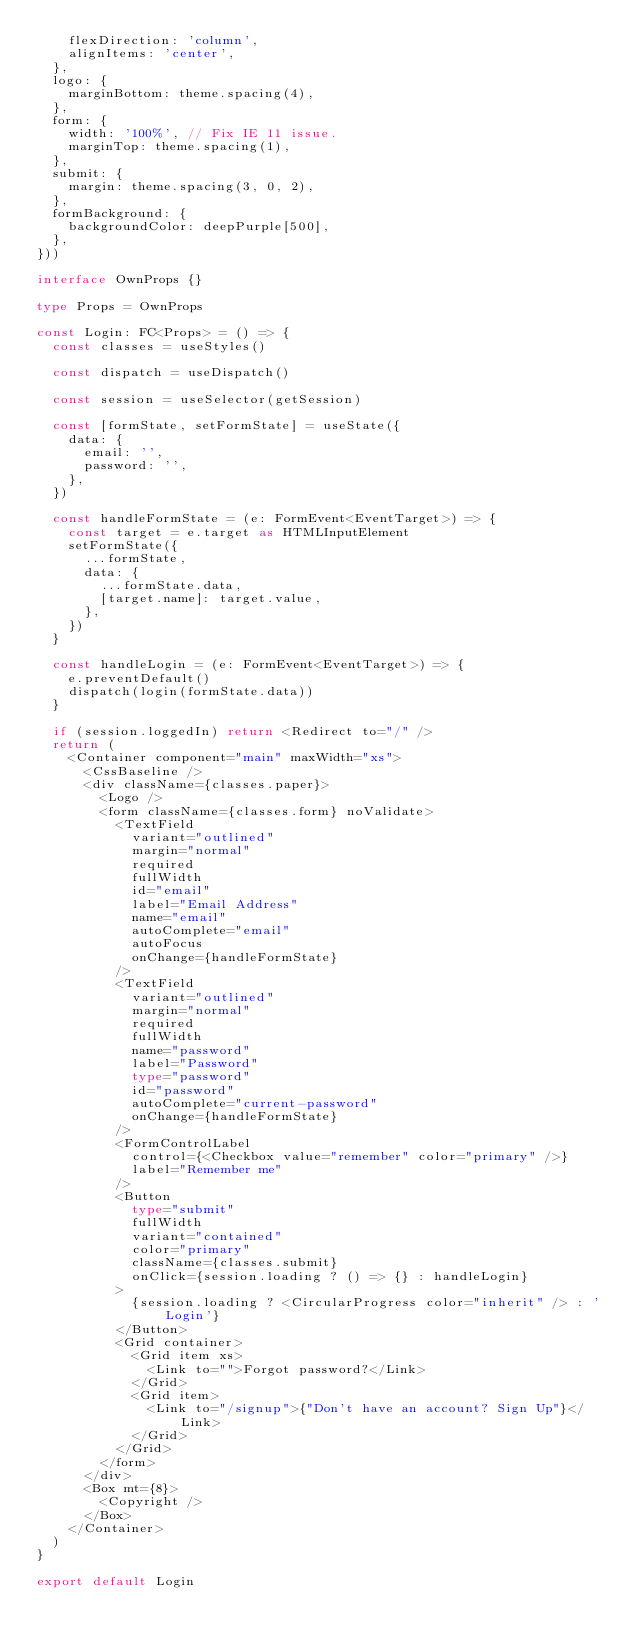<code> <loc_0><loc_0><loc_500><loc_500><_TypeScript_>    flexDirection: 'column',
    alignItems: 'center',
  },
  logo: {
    marginBottom: theme.spacing(4),
  },
  form: {
    width: '100%', // Fix IE 11 issue.
    marginTop: theme.spacing(1),
  },
  submit: {
    margin: theme.spacing(3, 0, 2),
  },
  formBackground: {
    backgroundColor: deepPurple[500],
  },
}))

interface OwnProps {}

type Props = OwnProps

const Login: FC<Props> = () => {
  const classes = useStyles()

  const dispatch = useDispatch()

  const session = useSelector(getSession)

  const [formState, setFormState] = useState({
    data: {
      email: '',
      password: '',
    },
  })

  const handleFormState = (e: FormEvent<EventTarget>) => {
    const target = e.target as HTMLInputElement
    setFormState({
      ...formState,
      data: {
        ...formState.data,
        [target.name]: target.value,
      },
    })
  }

  const handleLogin = (e: FormEvent<EventTarget>) => {
    e.preventDefault()
    dispatch(login(formState.data))
  }

  if (session.loggedIn) return <Redirect to="/" />
  return (
    <Container component="main" maxWidth="xs">
      <CssBaseline />
      <div className={classes.paper}>
        <Logo />
        <form className={classes.form} noValidate>
          <TextField
            variant="outlined"
            margin="normal"
            required
            fullWidth
            id="email"
            label="Email Address"
            name="email"
            autoComplete="email"
            autoFocus
            onChange={handleFormState}
          />
          <TextField
            variant="outlined"
            margin="normal"
            required
            fullWidth
            name="password"
            label="Password"
            type="password"
            id="password"
            autoComplete="current-password"
            onChange={handleFormState}
          />
          <FormControlLabel
            control={<Checkbox value="remember" color="primary" />}
            label="Remember me"
          />
          <Button
            type="submit"
            fullWidth
            variant="contained"
            color="primary"
            className={classes.submit}
            onClick={session.loading ? () => {} : handleLogin}
          >
            {session.loading ? <CircularProgress color="inherit" /> : 'Login'}
          </Button>
          <Grid container>
            <Grid item xs>
              <Link to="">Forgot password?</Link>
            </Grid>
            <Grid item>
              <Link to="/signup">{"Don't have an account? Sign Up"}</Link>
            </Grid>
          </Grid>
        </form>
      </div>
      <Box mt={8}>
        <Copyright />
      </Box>
    </Container>
  )
}

export default Login
</code> 